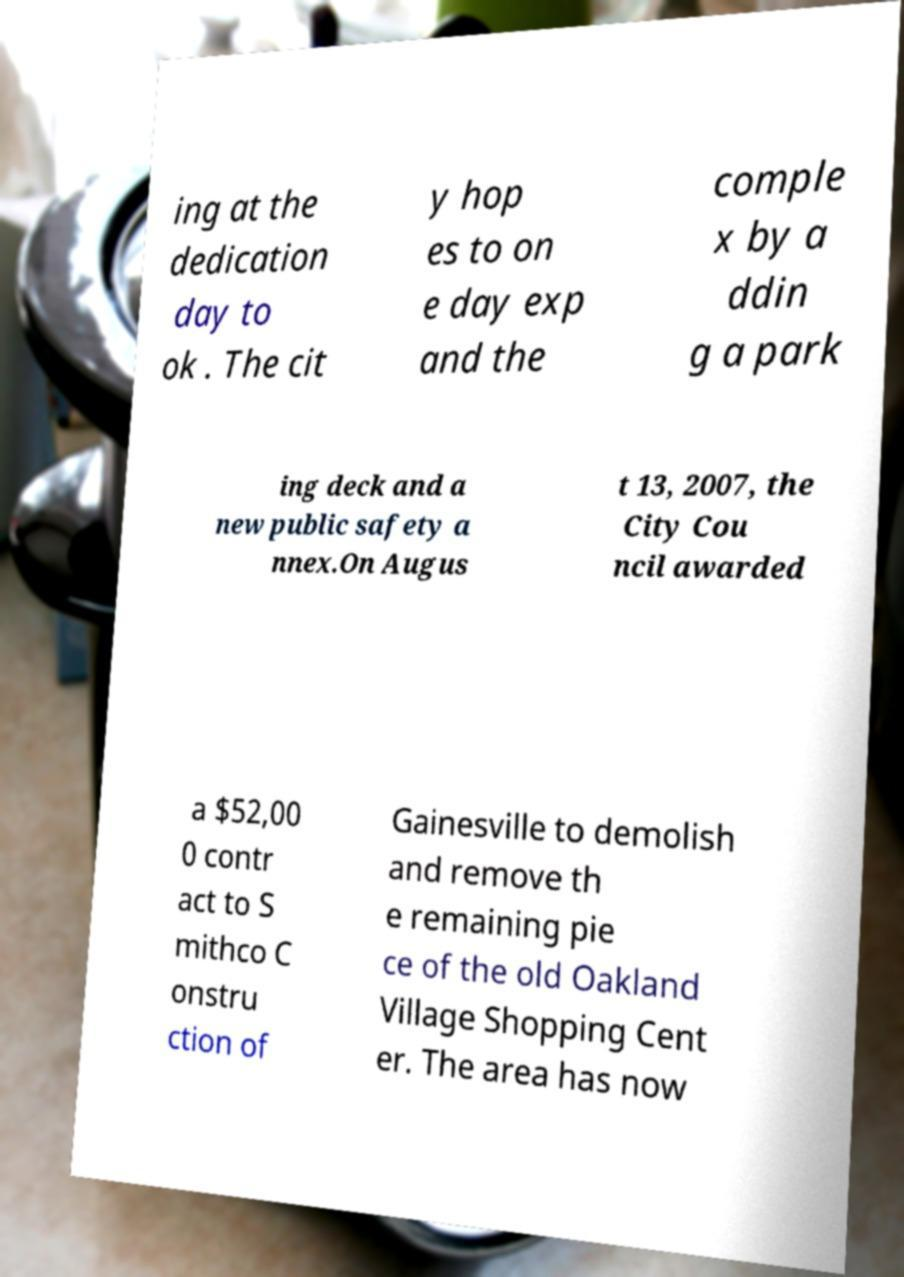I need the written content from this picture converted into text. Can you do that? ing at the dedication day to ok . The cit y hop es to on e day exp and the comple x by a ddin g a park ing deck and a new public safety a nnex.On Augus t 13, 2007, the City Cou ncil awarded a $52,00 0 contr act to S mithco C onstru ction of Gainesville to demolish and remove th e remaining pie ce of the old Oakland Village Shopping Cent er. The area has now 